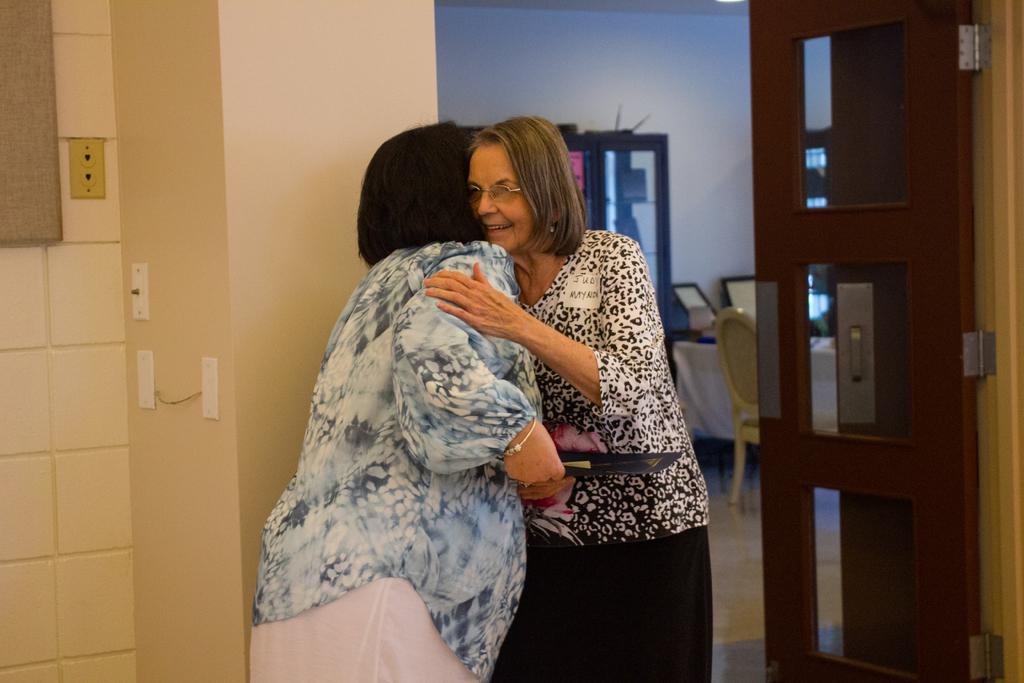What type of structure can be seen in the image? There is a wall in the image. What feature allows light and air into the room? There is a window in the image. What type of flooring is present in the image? White color tiles are present in the image. What type of furniture is visible in the image? There are chairs and a table in the image. How can one enter or exit the room? There is a door in the image. Who is present in the image? Two women are standing in the front of the image. What type of grain is being harvested in the image? There is no grain or harvesting activity present in the image. How does the smoke from the fireplace affect the air quality in the room? There is no fireplace or smoke present in the image. 